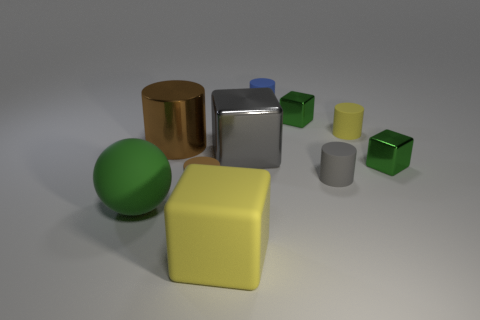Is the number of yellow things greater than the number of big objects? Based on the image, there are a total of two yellow objects, one of which is a large cube and the other a smaller cylinder. When evaluating the size of objects in the scene, there are several big objects that include the large yellow cube, a large green sphere, a large silver cylinder, and a large gold cylinder. So the number of yellow objects is not greater than the number of big objects. 